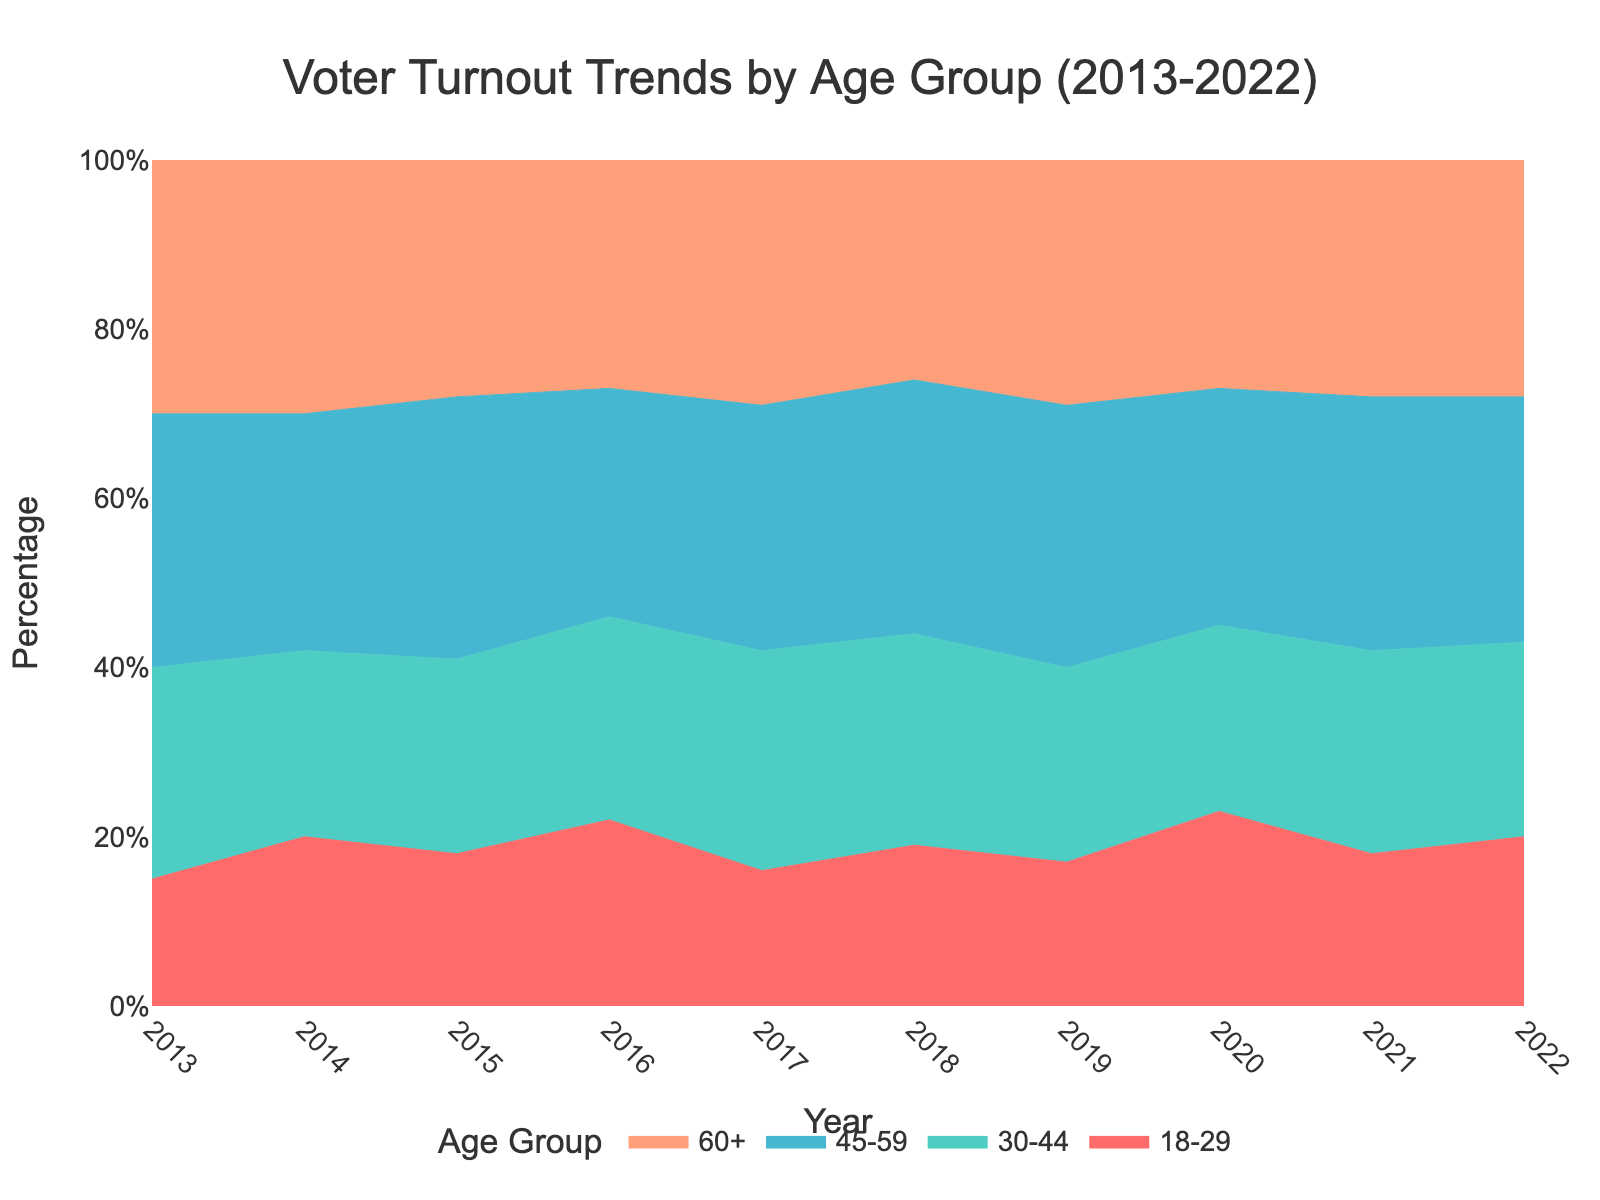what is the title of the figure? The title is typically found at the very top of the figure. In this case, it reads: "Voter Turnout Trends by Age Group (2013-2022)"
Answer: Voter Turnout Trends by Age Group (2013-2022) How did the percentage of voters aged 18-29 change between 2013 and 2022? To determine the change, look at the heights of the 18-29 age group's section at both the start (2013) and end (2022) of the chart. In 2013 it was around 15%, and in 2022 it reached around 20%.
Answer: Increased by 5% Which age group showed the most consistent voter turnout trend over the decade? Consistency can be observed by looking for the least fluctuation in the width of the bands for each age group. The 60+ group remained around 27-30% throughout the decade, displaying the most consistency.
Answer: 60+ In which year did the 45-59 age group have the highest percentage of voter turnout? Check for the peak height of the 45-59 age group's section over the years. The highest percentage comes in 2015 with a turnout around 31%.
Answer: 2015 What is the range of voter turnout percentages for the 30-44 age group across the decade? To find the range, identify the highest and lowest percentages for the 30-44 age group. The highest is around 26% in 2017 and the lowest is approximately 22% in 2014 and 2020.
Answer: 22% to 26% Compare the voter turnout percentage between the 30-44 and 60+ age groups in 2018. Which group had a higher percentage? Look at the respective segments for both age groups in 2018. The 30-44 age group had around 25%, while the 60+ group had about 26%.
Answer: 60+ had a higher percentage What was the trend in voter turnout for the age group 18-29 from 2019 to 2020? Observe the change in the width of the 18-29 band's segment from 2019 to 2020. There was an increase from 17% in 2019 to 23% in 2020.
Answer: Increased Which age group had the lowest voter turnout in 2017? Identify the shortest segment in the stacked area chart for 2017. The 18-29 age group had the lowest percentage around 16%.
Answer: 18-29 How did the percentage of voters aged 60+ change from 2015 to 2016? Compare the widths of the 60+ segments for these two years. It was around 28% in 2015 and remained at about the same level in 2016, roughly 27%.
Answer: Decreased slightly by 1% What is the average voter turnout for the 45-59 age group over the entire period? Sum the percentages for the 45-59 age group from 2013 to 2022 and then divide by 10. The values are 30, 28, 31, 27, 29, 30, 31, 28, 30, 29, summing up to 293, so the average is 293/10 = 29.3%.
Answer: 29.3% 